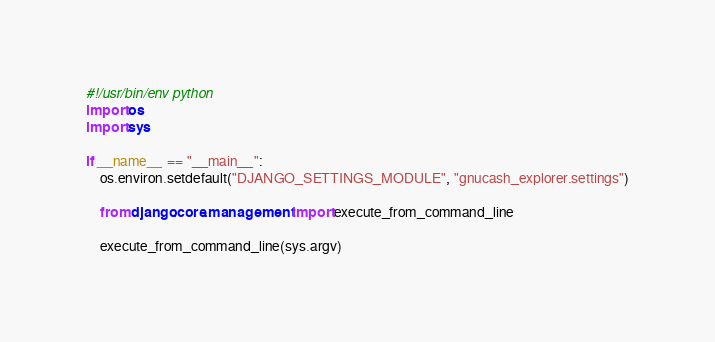Convert code to text. <code><loc_0><loc_0><loc_500><loc_500><_Python_>#!/usr/bin/env python
import os
import sys

if __name__ == "__main__":
    os.environ.setdefault("DJANGO_SETTINGS_MODULE", "gnucash_explorer.settings")

    from django.core.management import execute_from_command_line

    execute_from_command_line(sys.argv)
</code> 